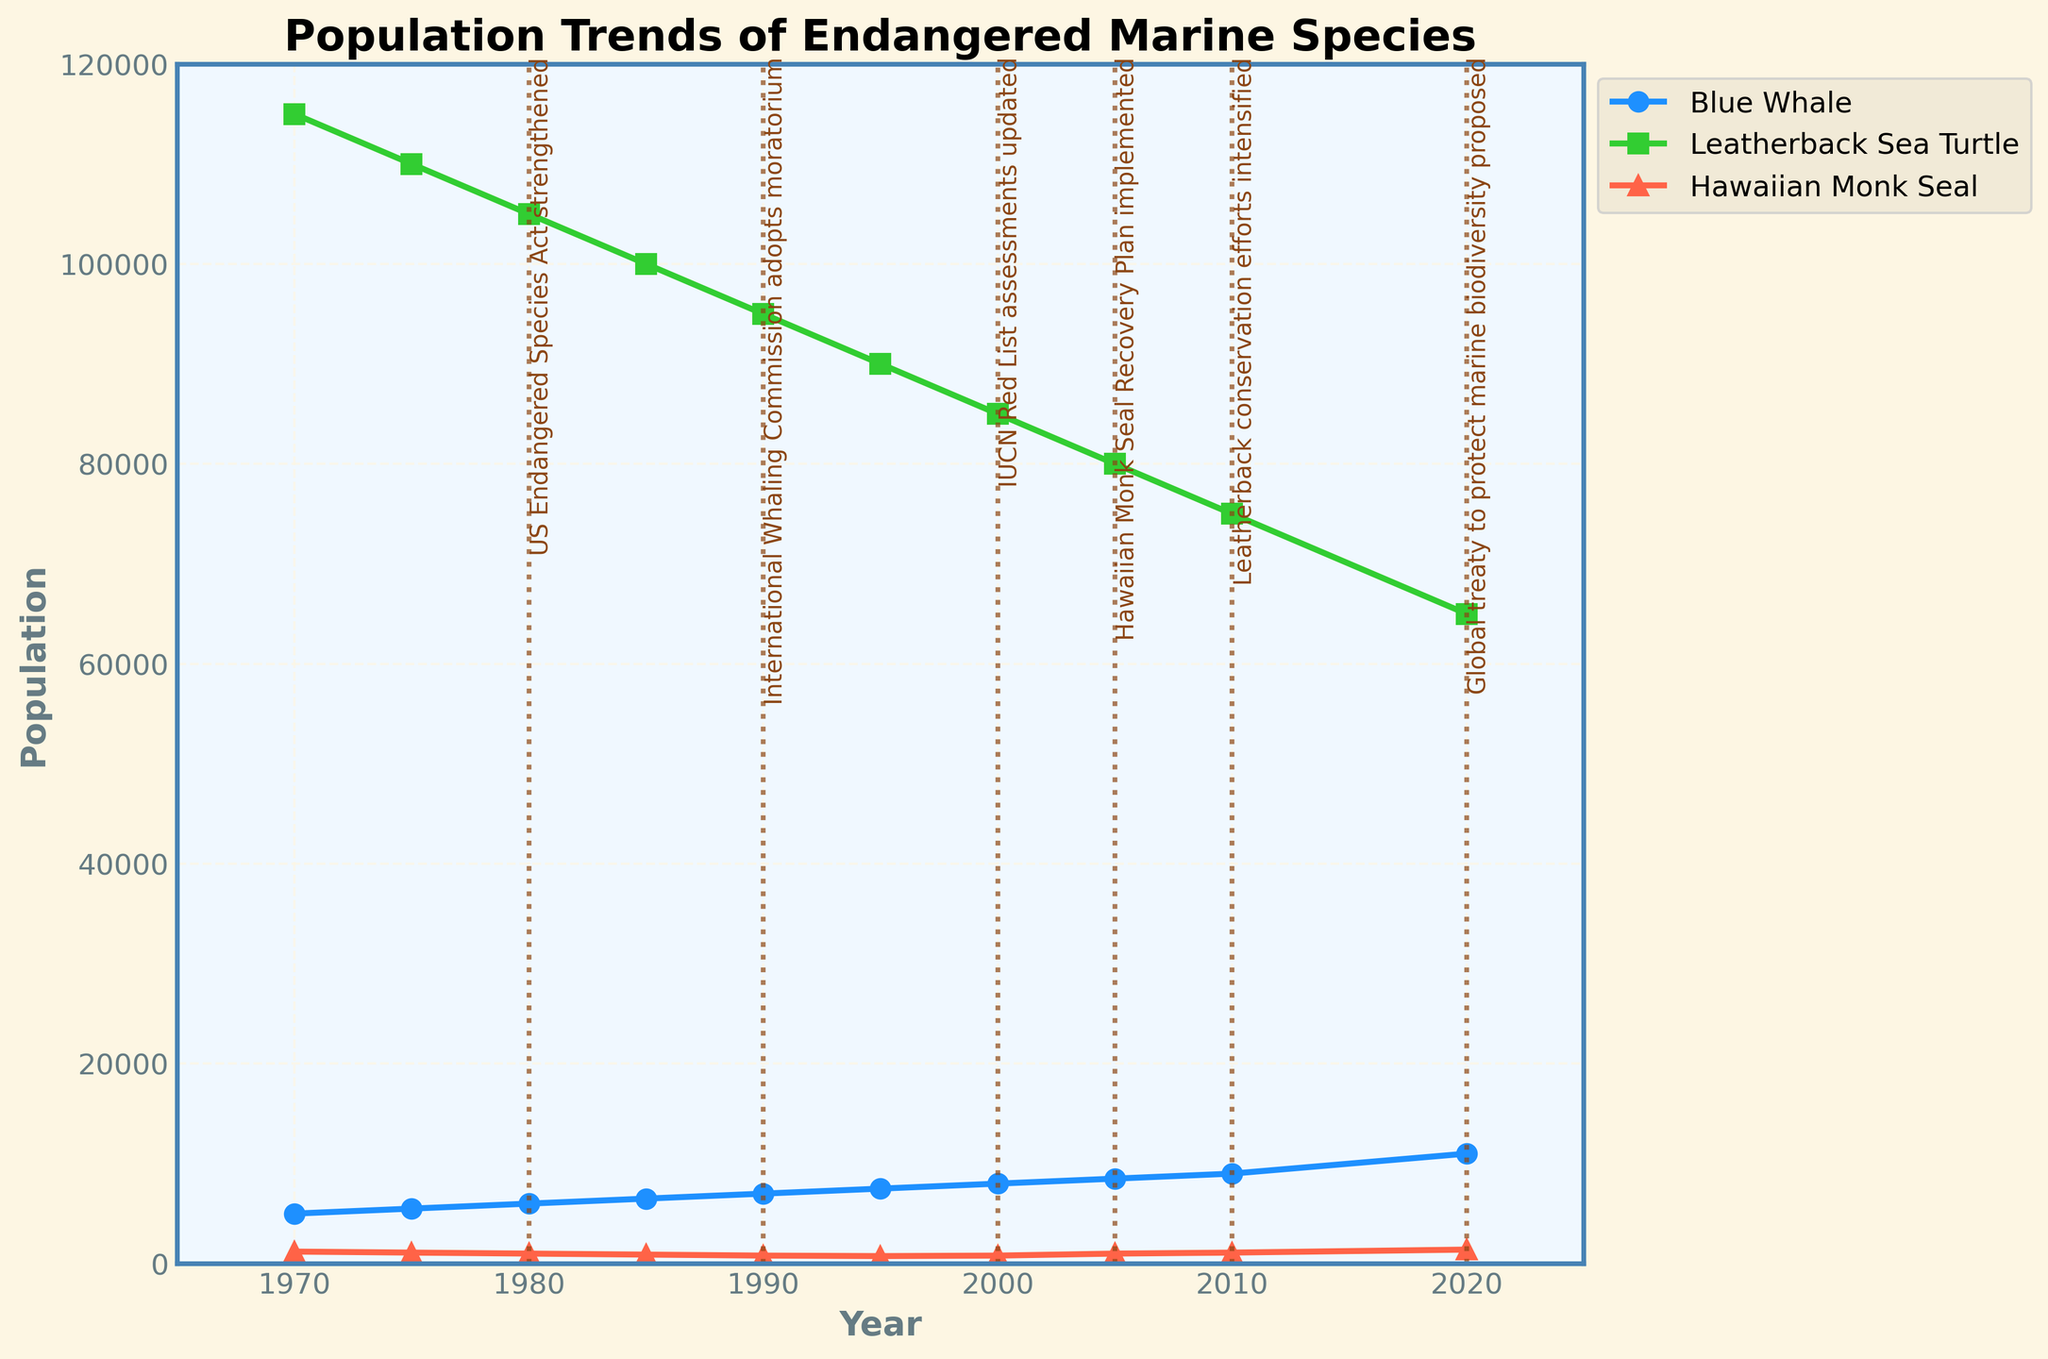How has the population of Blue Whales changed from 1970 to 2020? Identify the Blue Whale line from 1970 and 2020, then subtract the initial value from the final value: 11000 - 5000 = 6000.
Answer: 6000 What year saw the lowest population of Hawaiian Monk Seals, and what was the population? Locate the minimum point on the Hawaiian Monk Seal line and note the corresponding year and population: 1995 with a population of 750.
Answer: 1995, 750 How does the trend for Leatherback Sea Turtles differ from the Blue Whale over the 50-year period? Compare the direction and changes of both lines: Blue Whale increases steadily, while the Leatherback Sea Turtle shows a continuous decline.
Answer: Blue Whale increases, Leatherback Sea Turtle declines What was the population difference between the Hawaiian Monk Seal in 1980 and 2005? Find population values for 1980 and 2005 on the Hawaiian Monk Seal line and calculate the difference: 1000 - 1000 = 0.
Answer: 0 Which conservation milestone corresponds with the most significant population increase in Hawaiian Monk Seals, and by how much did it increase? Identify the milestones and note the population increase at those points. The largest increase is between 2005 and 2010 due to the "Hawaiian Monk Seal Recovery Plan implemented" with an increase of 1000 - 1100 = 100.
Answer: Hawaiian Monk Seal Recovery Plan, 100 What is the general visual pattern of the Leatherback Sea Turtle population over the years? Observe the Leatherback Sea Turtle line's visual pattern: there is a consistent downward trend.
Answer: Downward trend How has the population of Blue Whales changed relative to the milestones? Compare the Blue Whale line with the positions of conservation milestones: increases steadily, with some noticeable jumps around milestone years like 1980 and 1990.
Answer: Steady increase with jumps around milestones Between which years did the population of Leatherback Sea Turtles decrease the most sharply? Observe the largest decline by comparing the slopes of each segment: the steepest decline occurs between 2010 and 2020.
Answer: 2010 to 2020 In what way did the "International Whaling Commission adopts moratorium" impact the species' populations? Locate the 1990 milestone and observe the nearby trends for all species: Blue Whale population increased significantly post-1990.
Answer: Blue Whale population increase Which species had the most stable population over the last 50 years? Compare the fluctuation of each line: Hawaiian Monk Seal shows more fluctuations, Leatherback Sea Turtle declines steadily, Blue Whale increases steadily.
Answer: Blue Whale 